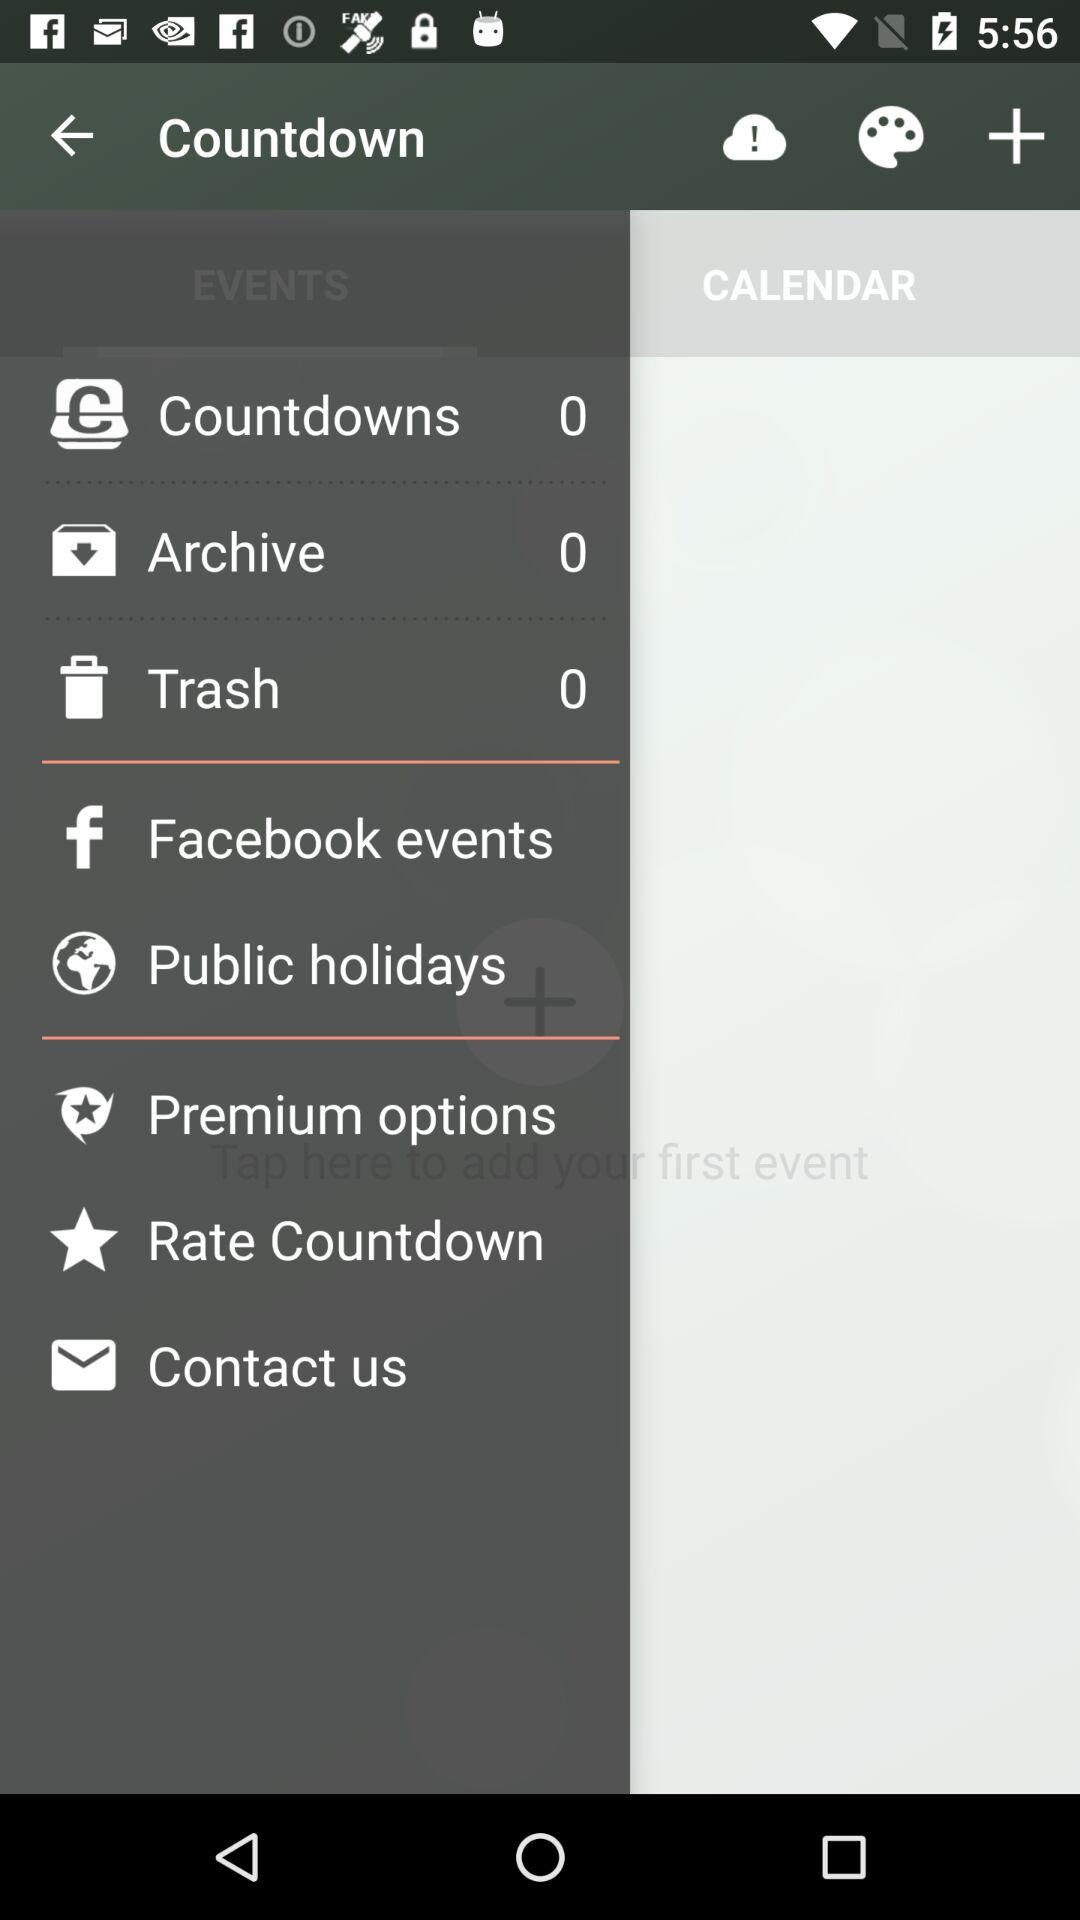What is the number of trash? The number of trash is 0. 